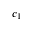<formula> <loc_0><loc_0><loc_500><loc_500>c _ { 1 }</formula> 